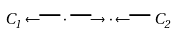Convert formula to latex. <formula><loc_0><loc_0><loc_500><loc_500>C _ { 1 } \longleftarrow \cdot \longrightarrow \cdot \longleftarrow C _ { 2 }</formula> 